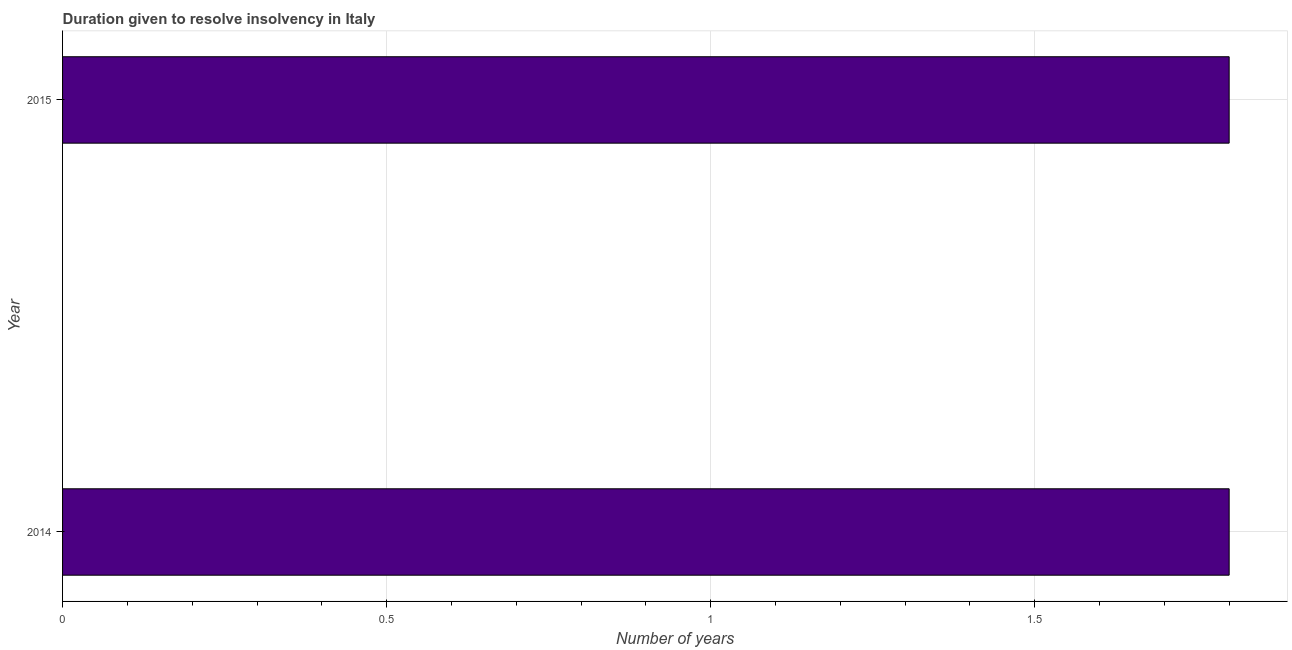Does the graph contain any zero values?
Give a very brief answer. No. Does the graph contain grids?
Give a very brief answer. Yes. What is the title of the graph?
Your response must be concise. Duration given to resolve insolvency in Italy. What is the label or title of the X-axis?
Your response must be concise. Number of years. What is the label or title of the Y-axis?
Keep it short and to the point. Year. Across all years, what is the maximum number of years to resolve insolvency?
Your answer should be compact. 1.8. Across all years, what is the minimum number of years to resolve insolvency?
Offer a terse response. 1.8. In which year was the number of years to resolve insolvency minimum?
Provide a short and direct response. 2014. What is the sum of the number of years to resolve insolvency?
Keep it short and to the point. 3.6. What is the difference between the number of years to resolve insolvency in 2014 and 2015?
Your answer should be very brief. 0. Do a majority of the years between 2015 and 2014 (inclusive) have number of years to resolve insolvency greater than 1.4 ?
Keep it short and to the point. No. What is the ratio of the number of years to resolve insolvency in 2014 to that in 2015?
Give a very brief answer. 1. Is the number of years to resolve insolvency in 2014 less than that in 2015?
Provide a succinct answer. No. Are the values on the major ticks of X-axis written in scientific E-notation?
Your answer should be very brief. No. What is the Number of years of 2014?
Provide a succinct answer. 1.8. What is the Number of years of 2015?
Keep it short and to the point. 1.8. 